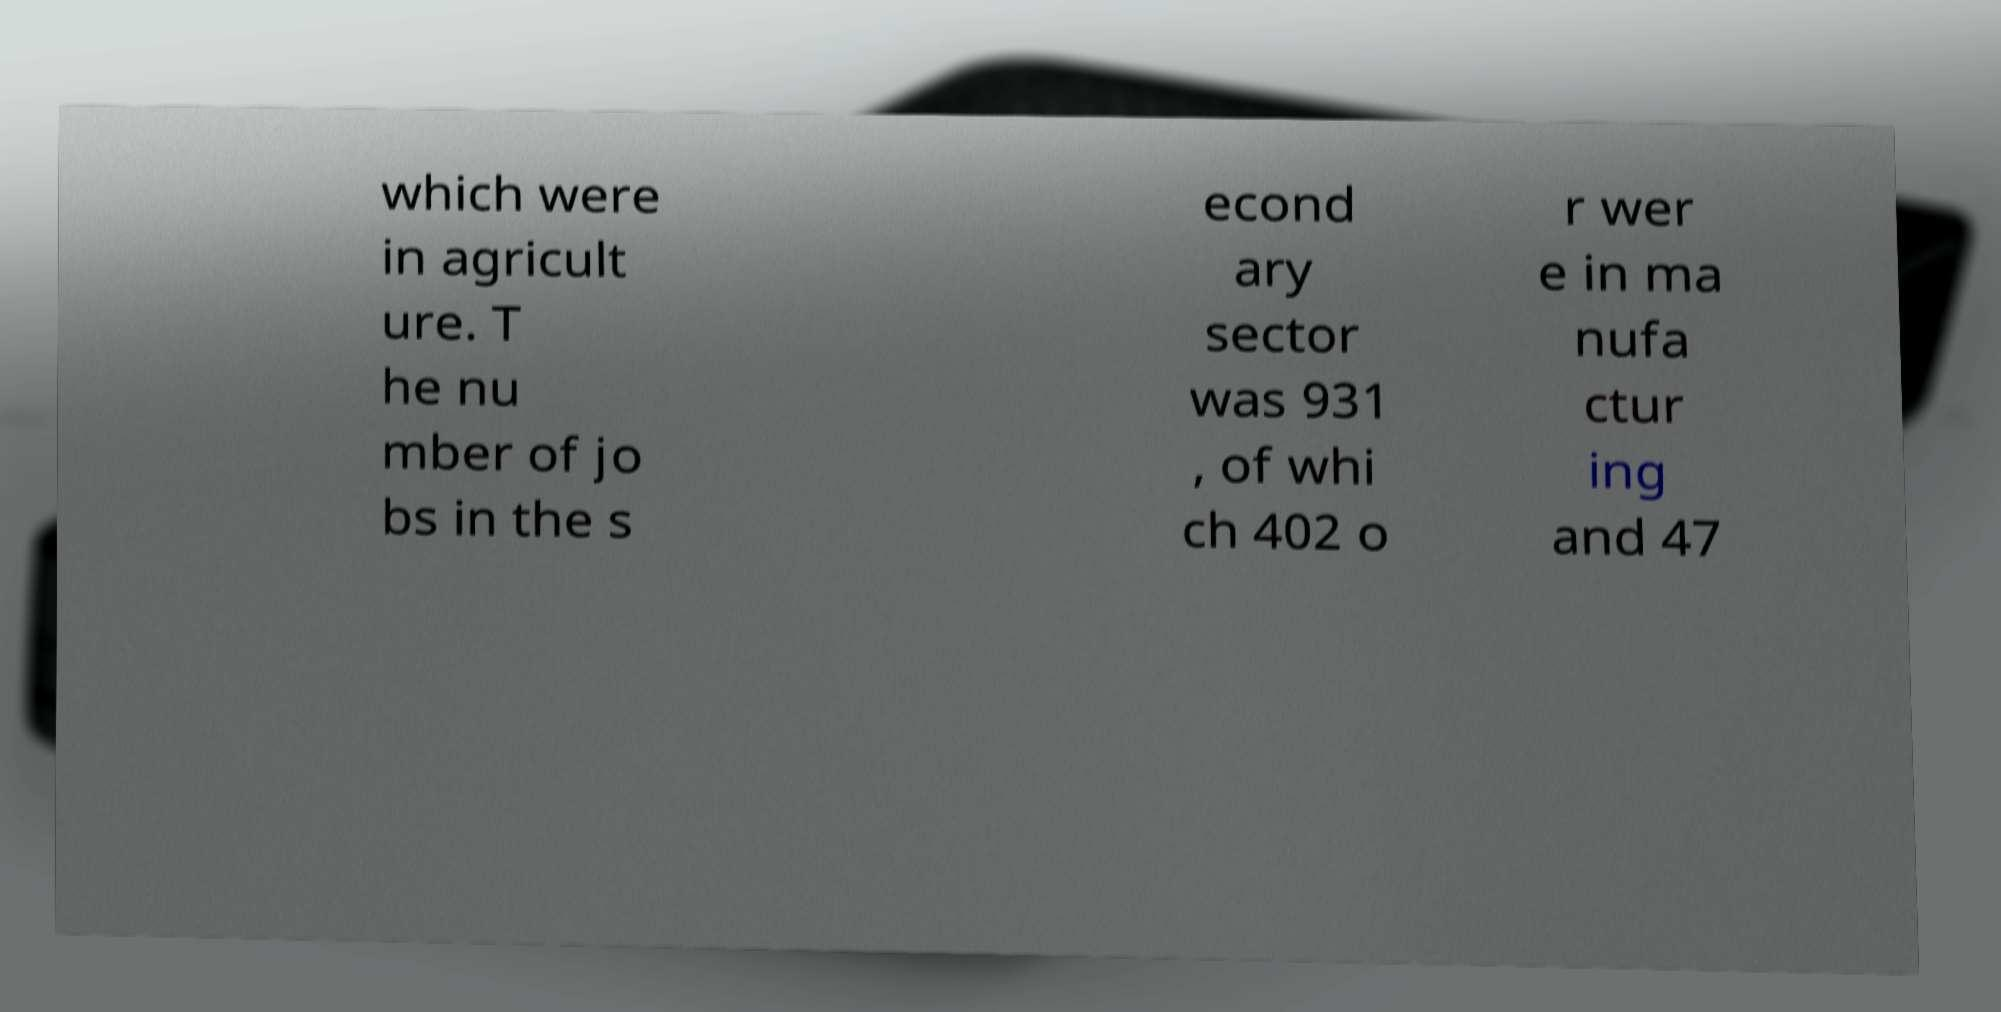Could you extract and type out the text from this image? which were in agricult ure. T he nu mber of jo bs in the s econd ary sector was 931 , of whi ch 402 o r wer e in ma nufa ctur ing and 47 